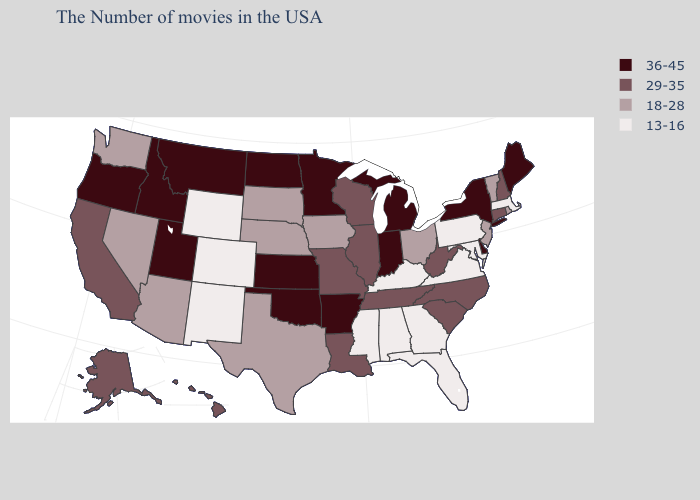Among the states that border Montana , does Wyoming have the lowest value?
Keep it brief. Yes. Name the states that have a value in the range 29-35?
Give a very brief answer. New Hampshire, Connecticut, North Carolina, South Carolina, West Virginia, Tennessee, Wisconsin, Illinois, Louisiana, Missouri, California, Alaska, Hawaii. Among the states that border Ohio , does West Virginia have the highest value?
Concise answer only. No. Name the states that have a value in the range 18-28?
Concise answer only. Rhode Island, Vermont, New Jersey, Ohio, Iowa, Nebraska, Texas, South Dakota, Arizona, Nevada, Washington. Which states have the highest value in the USA?
Answer briefly. Maine, New York, Delaware, Michigan, Indiana, Arkansas, Minnesota, Kansas, Oklahoma, North Dakota, Utah, Montana, Idaho, Oregon. What is the value of Pennsylvania?
Be succinct. 13-16. Does West Virginia have the highest value in the USA?
Short answer required. No. What is the lowest value in the USA?
Keep it brief. 13-16. What is the value of South Carolina?
Be succinct. 29-35. What is the value of Massachusetts?
Answer briefly. 13-16. What is the value of Michigan?
Give a very brief answer. 36-45. What is the highest value in the West ?
Keep it brief. 36-45. Name the states that have a value in the range 13-16?
Short answer required. Massachusetts, Maryland, Pennsylvania, Virginia, Florida, Georgia, Kentucky, Alabama, Mississippi, Wyoming, Colorado, New Mexico. What is the lowest value in states that border Oregon?
Short answer required. 18-28. Name the states that have a value in the range 18-28?
Quick response, please. Rhode Island, Vermont, New Jersey, Ohio, Iowa, Nebraska, Texas, South Dakota, Arizona, Nevada, Washington. 